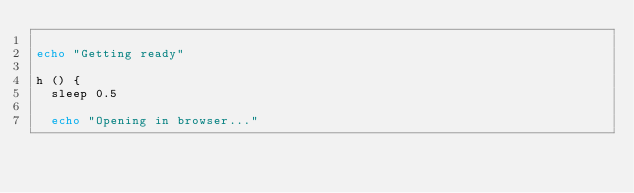Convert code to text. <code><loc_0><loc_0><loc_500><loc_500><_Bash_>
echo "Getting ready"

h () {
  sleep 0.5

  echo "Opening in browser..."
</code> 